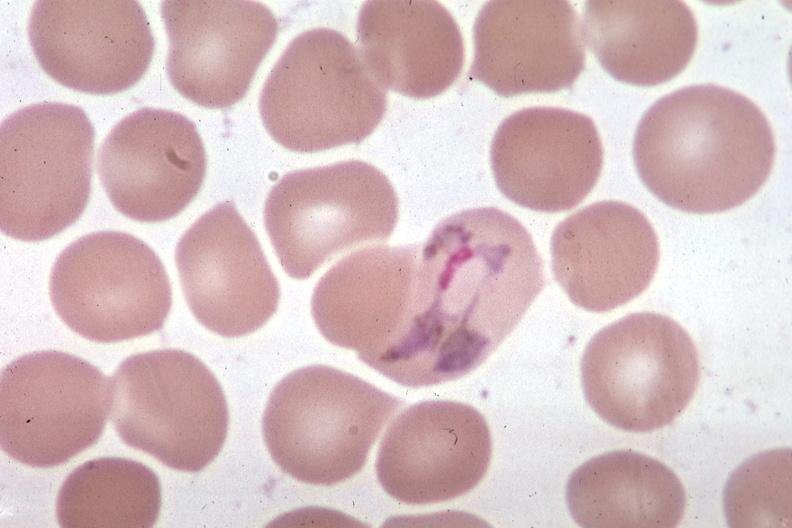s blood present?
Answer the question using a single word or phrase. Yes 